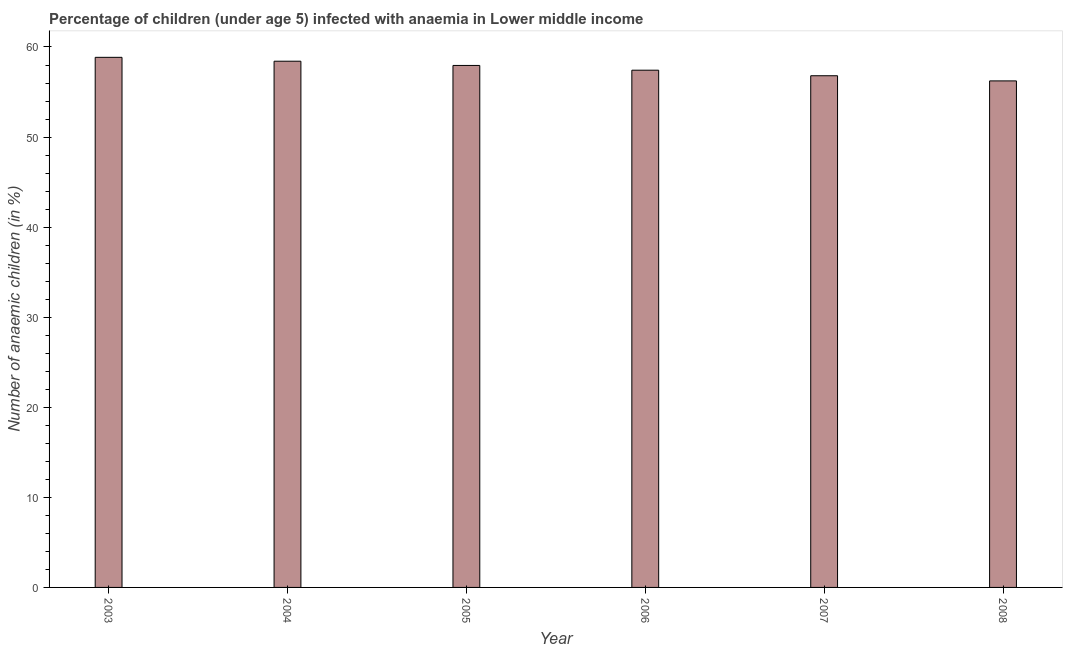Does the graph contain any zero values?
Make the answer very short. No. Does the graph contain grids?
Offer a terse response. No. What is the title of the graph?
Offer a terse response. Percentage of children (under age 5) infected with anaemia in Lower middle income. What is the label or title of the Y-axis?
Your answer should be compact. Number of anaemic children (in %). What is the number of anaemic children in 2007?
Offer a terse response. 56.81. Across all years, what is the maximum number of anaemic children?
Offer a very short reply. 58.85. Across all years, what is the minimum number of anaemic children?
Offer a terse response. 56.24. What is the sum of the number of anaemic children?
Make the answer very short. 345.69. What is the difference between the number of anaemic children in 2003 and 2007?
Offer a very short reply. 2.04. What is the average number of anaemic children per year?
Make the answer very short. 57.62. What is the median number of anaemic children?
Your response must be concise. 57.69. What is the ratio of the number of anaemic children in 2004 to that in 2007?
Offer a very short reply. 1.03. What is the difference between the highest and the second highest number of anaemic children?
Keep it short and to the point. 0.43. Is the sum of the number of anaemic children in 2005 and 2006 greater than the maximum number of anaemic children across all years?
Your answer should be compact. Yes. What is the difference between the highest and the lowest number of anaemic children?
Your answer should be compact. 2.62. How many bars are there?
Provide a short and direct response. 6. How many years are there in the graph?
Give a very brief answer. 6. What is the difference between two consecutive major ticks on the Y-axis?
Offer a terse response. 10. What is the Number of anaemic children (in %) of 2003?
Your response must be concise. 58.85. What is the Number of anaemic children (in %) of 2004?
Offer a very short reply. 58.42. What is the Number of anaemic children (in %) of 2005?
Keep it short and to the point. 57.95. What is the Number of anaemic children (in %) of 2006?
Give a very brief answer. 57.42. What is the Number of anaemic children (in %) of 2007?
Your answer should be very brief. 56.81. What is the Number of anaemic children (in %) in 2008?
Your answer should be very brief. 56.24. What is the difference between the Number of anaemic children (in %) in 2003 and 2004?
Offer a terse response. 0.43. What is the difference between the Number of anaemic children (in %) in 2003 and 2005?
Provide a short and direct response. 0.9. What is the difference between the Number of anaemic children (in %) in 2003 and 2006?
Make the answer very short. 1.43. What is the difference between the Number of anaemic children (in %) in 2003 and 2007?
Provide a succinct answer. 2.04. What is the difference between the Number of anaemic children (in %) in 2003 and 2008?
Your answer should be very brief. 2.62. What is the difference between the Number of anaemic children (in %) in 2004 and 2005?
Give a very brief answer. 0.47. What is the difference between the Number of anaemic children (in %) in 2004 and 2006?
Your answer should be compact. 1. What is the difference between the Number of anaemic children (in %) in 2004 and 2007?
Make the answer very short. 1.61. What is the difference between the Number of anaemic children (in %) in 2004 and 2008?
Ensure brevity in your answer.  2.19. What is the difference between the Number of anaemic children (in %) in 2005 and 2006?
Ensure brevity in your answer.  0.53. What is the difference between the Number of anaemic children (in %) in 2005 and 2007?
Offer a very short reply. 1.14. What is the difference between the Number of anaemic children (in %) in 2005 and 2008?
Offer a very short reply. 1.72. What is the difference between the Number of anaemic children (in %) in 2006 and 2007?
Provide a succinct answer. 0.62. What is the difference between the Number of anaemic children (in %) in 2006 and 2008?
Ensure brevity in your answer.  1.19. What is the difference between the Number of anaemic children (in %) in 2007 and 2008?
Give a very brief answer. 0.57. What is the ratio of the Number of anaemic children (in %) in 2003 to that in 2004?
Offer a very short reply. 1.01. What is the ratio of the Number of anaemic children (in %) in 2003 to that in 2006?
Offer a terse response. 1.02. What is the ratio of the Number of anaemic children (in %) in 2003 to that in 2007?
Ensure brevity in your answer.  1.04. What is the ratio of the Number of anaemic children (in %) in 2003 to that in 2008?
Keep it short and to the point. 1.05. What is the ratio of the Number of anaemic children (in %) in 2004 to that in 2007?
Make the answer very short. 1.03. What is the ratio of the Number of anaemic children (in %) in 2004 to that in 2008?
Keep it short and to the point. 1.04. What is the ratio of the Number of anaemic children (in %) in 2005 to that in 2007?
Ensure brevity in your answer.  1.02. What is the ratio of the Number of anaemic children (in %) in 2005 to that in 2008?
Give a very brief answer. 1.03. What is the ratio of the Number of anaemic children (in %) in 2007 to that in 2008?
Your response must be concise. 1.01. 